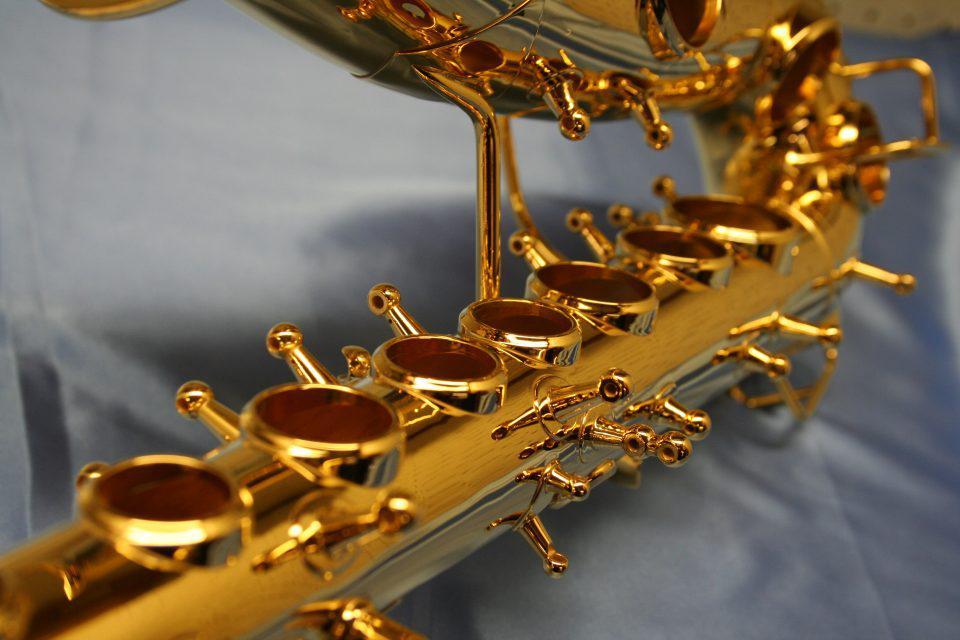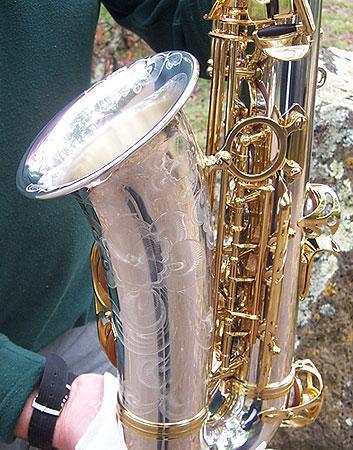The first image is the image on the left, the second image is the image on the right. Considering the images on both sides, is "Someone is playing a sax." valid? Answer yes or no. No. The first image is the image on the left, the second image is the image on the right. For the images shown, is this caption "One image shows a man playing a saxophone and standing in front of a row of upright instruments." true? Answer yes or no. No. 